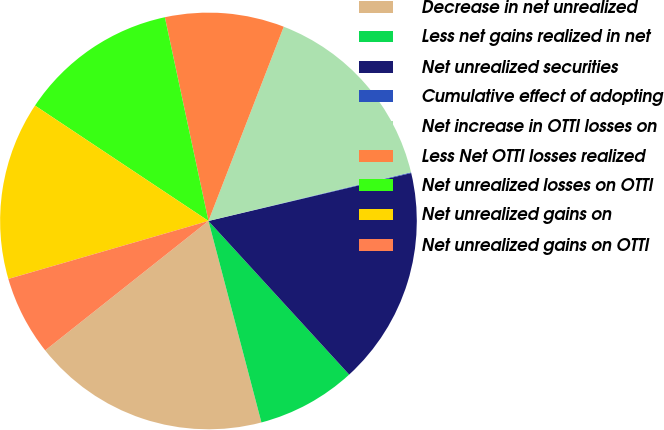Convert chart to OTSL. <chart><loc_0><loc_0><loc_500><loc_500><pie_chart><fcel>Decrease in net unrealized<fcel>Less net gains realized in net<fcel>Net unrealized securities<fcel>Cumulative effect of adopting<fcel>Net increase in OTTI losses on<fcel>Less Net OTTI losses realized<fcel>Net unrealized losses on OTTI<fcel>Net unrealized gains on<fcel>Net unrealized gains on OTTI<nl><fcel>18.42%<fcel>7.71%<fcel>16.89%<fcel>0.06%<fcel>15.36%<fcel>9.24%<fcel>12.3%<fcel>13.83%<fcel>6.18%<nl></chart> 